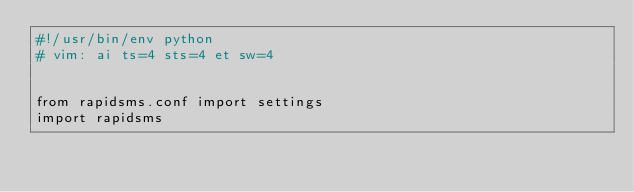Convert code to text. <code><loc_0><loc_0><loc_500><loc_500><_Python_>#!/usr/bin/env python
# vim: ai ts=4 sts=4 et sw=4


from rapidsms.conf import settings
import rapidsms

</code> 